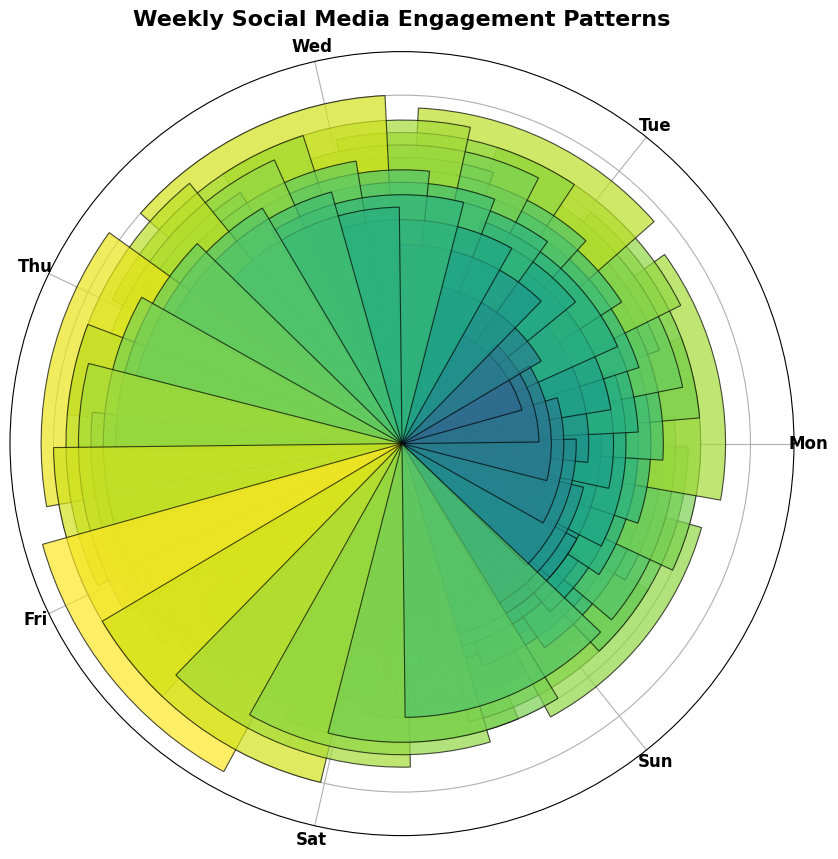What's the highest engagement level observed and on which day and hour does it occur? The highest bar in the rose chart represents the peak engagement level. This occurs at 150 on Sunday at 6 PM (1800 hrs).
Answer: 150 on Sunday at 6 PM How does the engagement level at 8 AM on Monday compare to 9 AM on Tuesday? Look for the bars corresponding to 8 AM on Monday and 9 AM on Tuesday. The bar for Monday at 8 AM is slightly lower than the bar for Tuesday at 9 AM.
Answer: Lower on Monday On which day does the engagement level have the widest range from lowest to highest? Calculate the range (difference between maximum and minimum values) for each day by observing the highest and lowest bars of each day. Sunday has the widest range from 50 to 150.
Answer: Sunday Which day has the highest engagement levels during the evening hours (6 PM to 12 AM)? Compare the evening bars (6 PM to 12 AM) for each day. Sunday has the highest engagement levels in the evening hours.
Answer: Sunday How does the engagement level change throughout the week during the early morning hours (3 AM to 7 AM)? Observe the heights of the bars for each day from 3 AM to 7 AM. The engagement levels gradually increase from Monday to Sunday during these hours.
Answer: Gradually increases Which day has the most consistent engagement levels throughout the day? Look for a day where the bar heights are relatively uniform. Thursday shows the most consistent engagement levels throughout the day.
Answer: Thursday By how much does the engagement level at 10 AM on Wednesday exceed the engagement level at 5 AM on Wednesday? Find the bar heights for Wednesday at 10 AM (80) and 5 AM (35) and calculate the difference. 80 - 35 = 45.
Answer: 45 What is the average engagement level at 9 PM across all days? Find the bar heights for 9 PM on each day (Monday 95, Tuesday 100, Wednesday 105, Thursday 110, Friday 115, Saturday 120, Sunday 125) and calculate the average: (95+100+105+110+115+120+125)/7 = 110.
Answer: 110 Which hour has shown the lowest overall engagement across the week? Compare the bar heights for each hour across all days. The lowest overall engagement is observed around 6 AM across all days.
Answer: 6 AM During what period of the day do we see the sharpest increase in engagement levels from one hour to the next? Identify periods where the bars show the steepest rise within one-day segments. The sharpest increase is seen on Sunday between 5 PM and 6 PM.
Answer: Between 5 PM and 6 PM on Sunday 